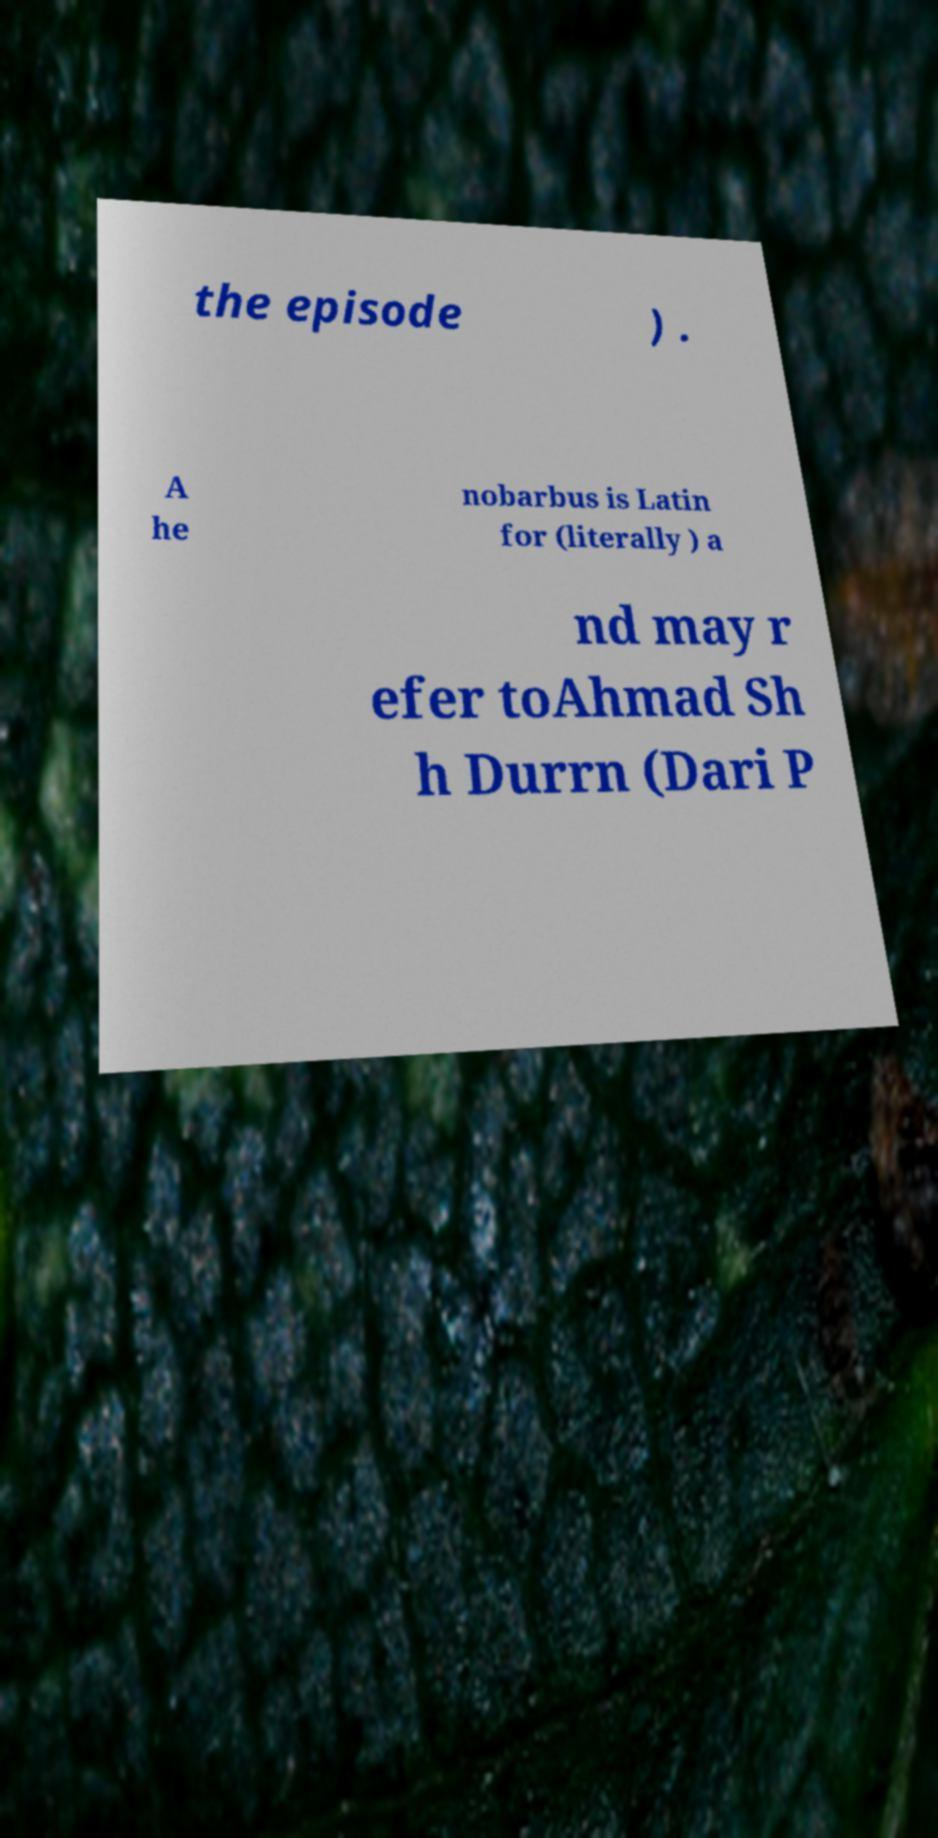Please read and relay the text visible in this image. What does it say? the episode ) . A he nobarbus is Latin for (literally ) a nd may r efer toAhmad Sh h Durrn (Dari P 